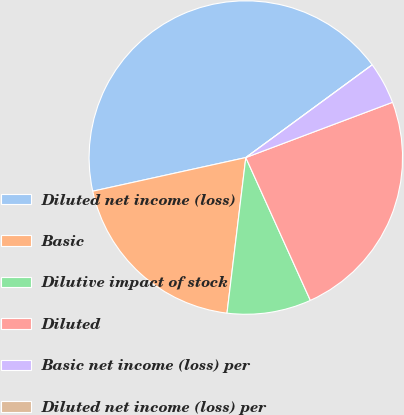Convert chart to OTSL. <chart><loc_0><loc_0><loc_500><loc_500><pie_chart><fcel>Diluted net income (loss)<fcel>Basic<fcel>Dilutive impact of stock<fcel>Diluted<fcel>Basic net income (loss) per<fcel>Diluted net income (loss) per<nl><fcel>43.37%<fcel>19.64%<fcel>8.67%<fcel>23.98%<fcel>4.34%<fcel>0.0%<nl></chart> 